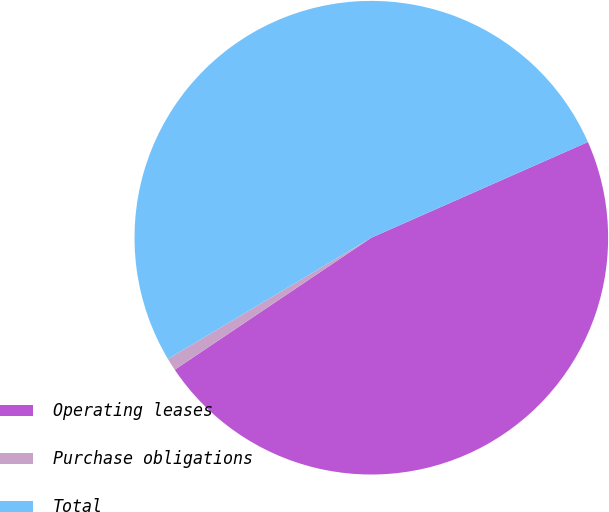Convert chart. <chart><loc_0><loc_0><loc_500><loc_500><pie_chart><fcel>Operating leases<fcel>Purchase obligations<fcel>Total<nl><fcel>47.21%<fcel>0.86%<fcel>51.93%<nl></chart> 